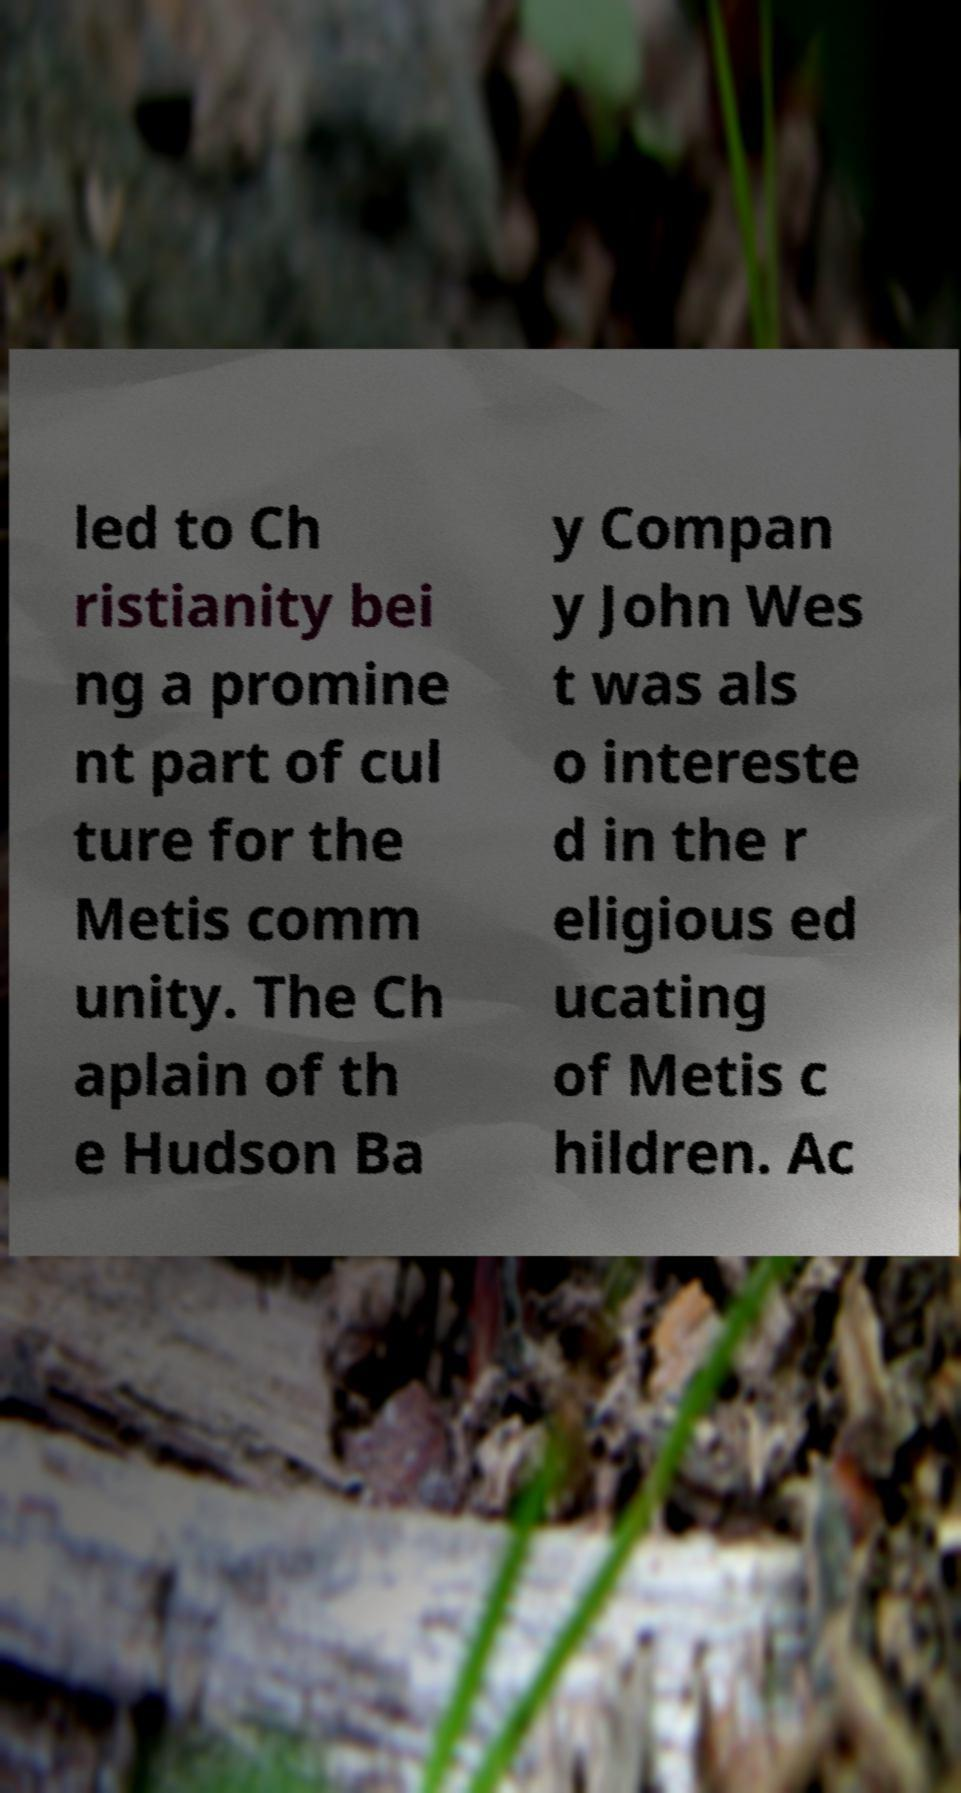Can you read and provide the text displayed in the image?This photo seems to have some interesting text. Can you extract and type it out for me? led to Ch ristianity bei ng a promine nt part of cul ture for the Metis comm unity. The Ch aplain of th e Hudson Ba y Compan y John Wes t was als o intereste d in the r eligious ed ucating of Metis c hildren. Ac 